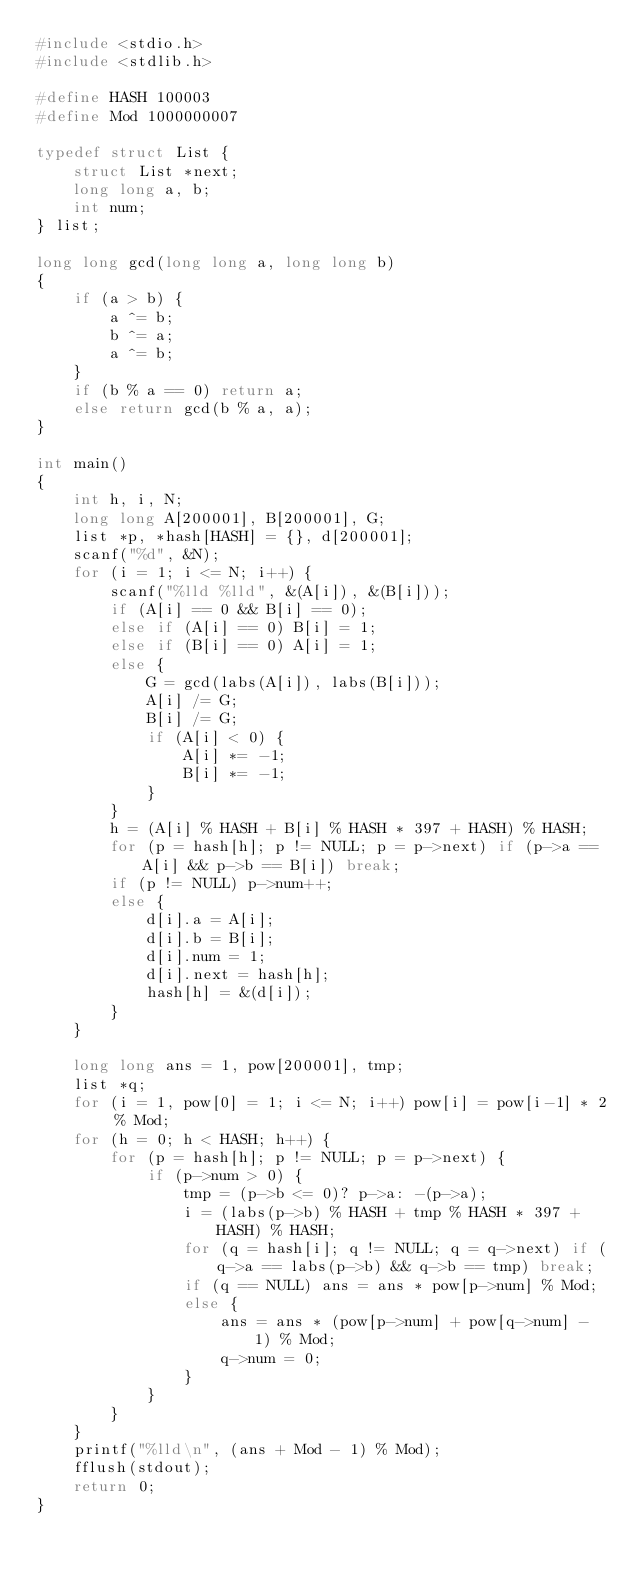<code> <loc_0><loc_0><loc_500><loc_500><_C_>#include <stdio.h>
#include <stdlib.h>

#define HASH 100003
#define Mod 1000000007

typedef struct List {
	struct List *next;
	long long a, b;
	int num;
} list;

long long gcd(long long a, long long b)
{
	if (a > b) {
		a ^= b;
		b ^= a;
		a ^= b;
	}
	if (b % a == 0) return a;
	else return gcd(b % a, a);
}

int main()
{
	int h, i, N;
	long long A[200001], B[200001], G;
	list *p, *hash[HASH] = {}, d[200001];
	scanf("%d", &N);
	for (i = 1; i <= N; i++) {
		scanf("%lld %lld", &(A[i]), &(B[i]));
		if (A[i] == 0 && B[i] == 0);
		else if (A[i] == 0) B[i] = 1;
		else if (B[i] == 0) A[i] = 1;
		else {
			G = gcd(labs(A[i]), labs(B[i]));
			A[i] /= G;
			B[i] /= G;
			if (A[i] < 0) {
				A[i] *= -1;
				B[i] *= -1;
			}
		}
		h = (A[i] % HASH + B[i] % HASH * 397 + HASH) % HASH;
		for (p = hash[h]; p != NULL; p = p->next) if (p->a == A[i] && p->b == B[i]) break;
		if (p != NULL) p->num++;
		else {
			d[i].a = A[i];
			d[i].b = B[i];
			d[i].num = 1;
			d[i].next = hash[h];
			hash[h] = &(d[i]);
		}
	}
	
	long long ans = 1, pow[200001], tmp;
	list *q;
	for (i = 1, pow[0] = 1; i <= N; i++) pow[i] = pow[i-1] * 2 % Mod;
	for (h = 0; h < HASH; h++) {
		for (p = hash[h]; p != NULL; p = p->next) {
			if (p->num > 0) {
				tmp = (p->b <= 0)? p->a: -(p->a);
				i = (labs(p->b) % HASH + tmp % HASH * 397 + HASH) % HASH;
				for (q = hash[i]; q != NULL; q = q->next) if (q->a == labs(p->b) && q->b == tmp) break;
				if (q == NULL) ans = ans * pow[p->num] % Mod;
				else {
					ans = ans * (pow[p->num] + pow[q->num] - 1) % Mod;
					q->num = 0;
				}
			}
		}
	}
	printf("%lld\n", (ans + Mod - 1) % Mod);
	fflush(stdout);
	return 0;
}</code> 